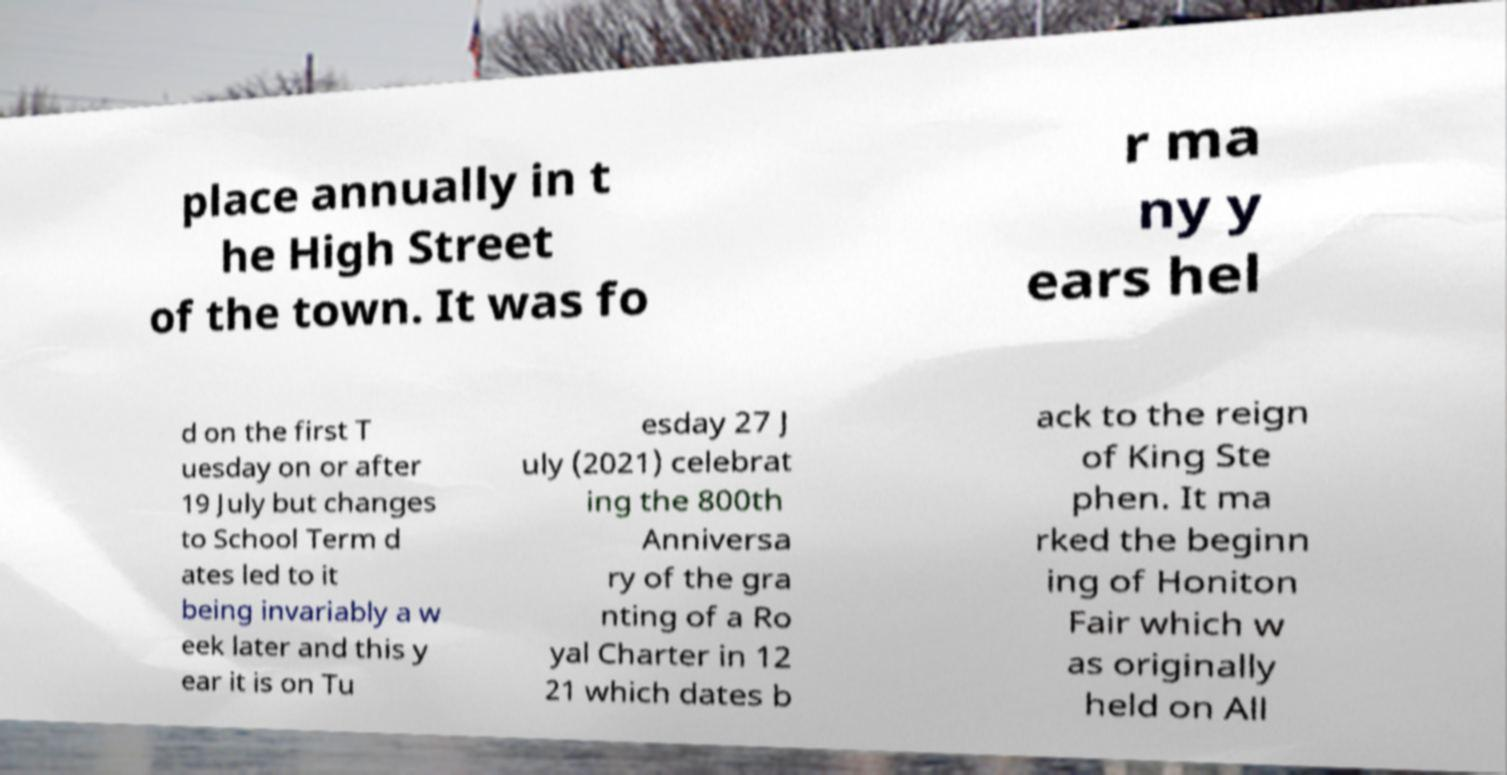Could you assist in decoding the text presented in this image and type it out clearly? place annually in t he High Street of the town. It was fo r ma ny y ears hel d on the first T uesday on or after 19 July but changes to School Term d ates led to it being invariably a w eek later and this y ear it is on Tu esday 27 J uly (2021) celebrat ing the 800th Anniversa ry of the gra nting of a Ro yal Charter in 12 21 which dates b ack to the reign of King Ste phen. It ma rked the beginn ing of Honiton Fair which w as originally held on All 